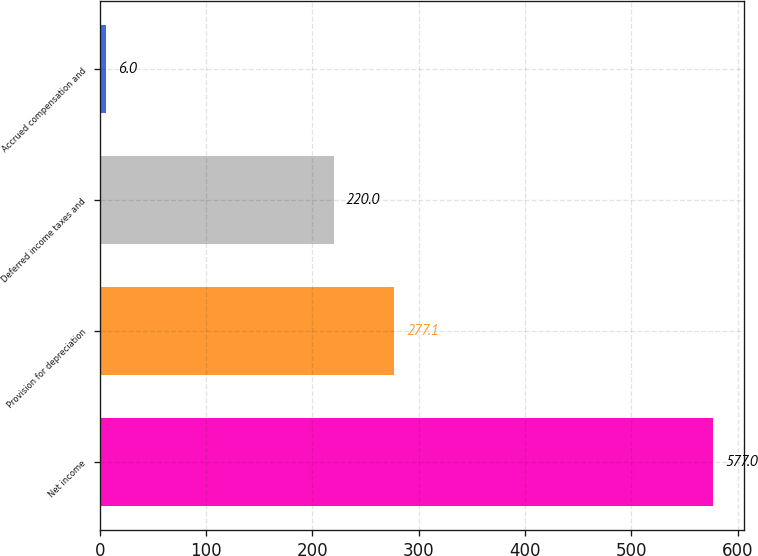<chart> <loc_0><loc_0><loc_500><loc_500><bar_chart><fcel>Net income<fcel>Provision for depreciation<fcel>Deferred income taxes and<fcel>Accrued compensation and<nl><fcel>577<fcel>277.1<fcel>220<fcel>6<nl></chart> 